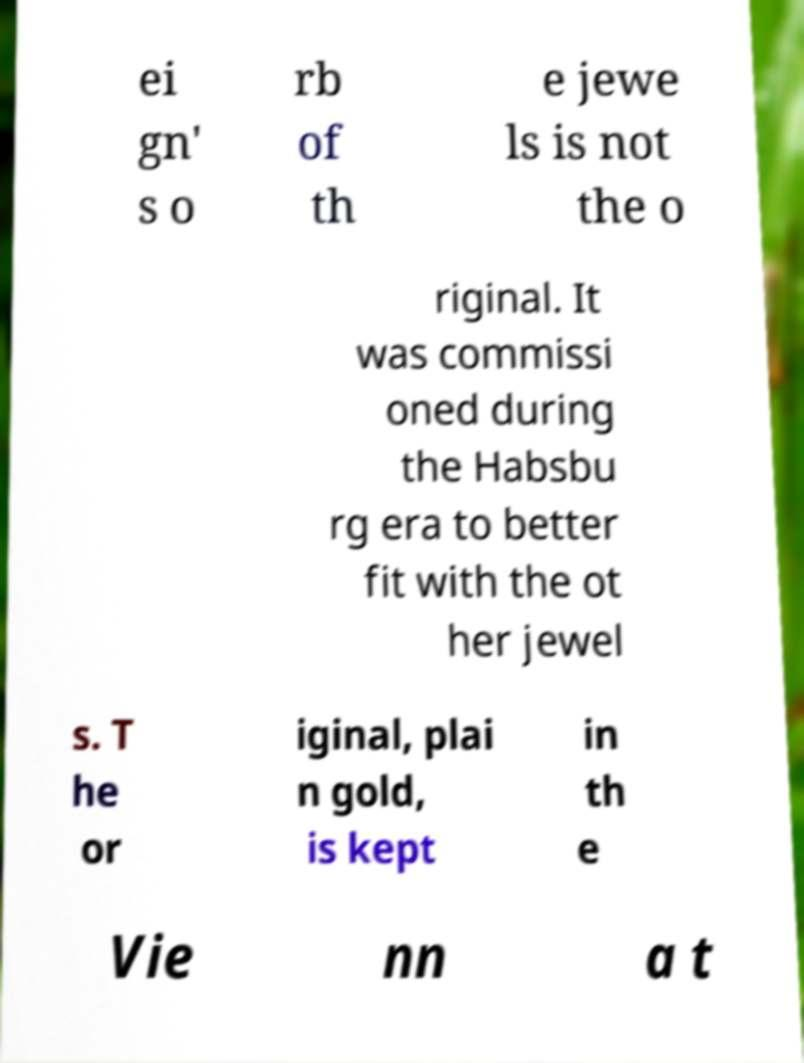I need the written content from this picture converted into text. Can you do that? ei gn' s o rb of th e jewe ls is not the o riginal. It was commissi oned during the Habsbu rg era to better fit with the ot her jewel s. T he or iginal, plai n gold, is kept in th e Vie nn a t 